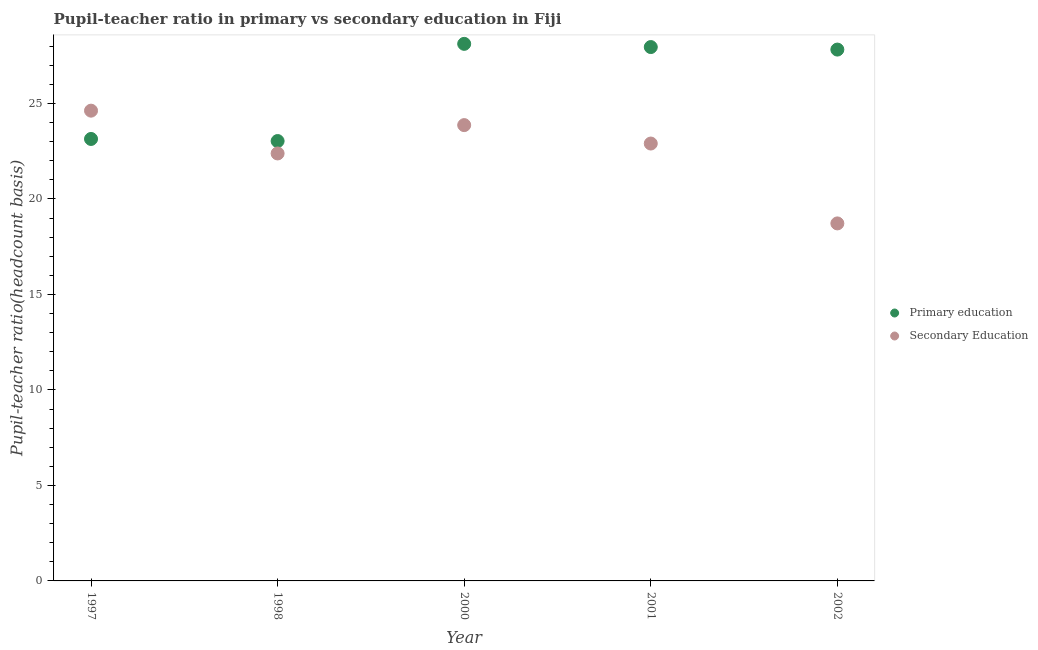How many different coloured dotlines are there?
Give a very brief answer. 2. Is the number of dotlines equal to the number of legend labels?
Your response must be concise. Yes. What is the pupil-teacher ratio in primary education in 2002?
Give a very brief answer. 27.82. Across all years, what is the maximum pupil teacher ratio on secondary education?
Your answer should be very brief. 24.62. Across all years, what is the minimum pupil teacher ratio on secondary education?
Provide a succinct answer. 18.72. In which year was the pupil-teacher ratio in primary education minimum?
Ensure brevity in your answer.  1998. What is the total pupil teacher ratio on secondary education in the graph?
Make the answer very short. 112.5. What is the difference between the pupil teacher ratio on secondary education in 2000 and that in 2001?
Your answer should be very brief. 0.97. What is the difference between the pupil teacher ratio on secondary education in 2001 and the pupil-teacher ratio in primary education in 2002?
Provide a succinct answer. -4.92. What is the average pupil teacher ratio on secondary education per year?
Provide a succinct answer. 22.5. In the year 1997, what is the difference between the pupil teacher ratio on secondary education and pupil-teacher ratio in primary education?
Make the answer very short. 1.48. In how many years, is the pupil-teacher ratio in primary education greater than 11?
Offer a very short reply. 5. What is the ratio of the pupil-teacher ratio in primary education in 2000 to that in 2001?
Keep it short and to the point. 1.01. Is the pupil teacher ratio on secondary education in 1998 less than that in 2000?
Keep it short and to the point. Yes. What is the difference between the highest and the second highest pupil teacher ratio on secondary education?
Your response must be concise. 0.76. What is the difference between the highest and the lowest pupil teacher ratio on secondary education?
Your answer should be compact. 5.9. In how many years, is the pupil-teacher ratio in primary education greater than the average pupil-teacher ratio in primary education taken over all years?
Provide a short and direct response. 3. Is the sum of the pupil teacher ratio on secondary education in 2001 and 2002 greater than the maximum pupil-teacher ratio in primary education across all years?
Your answer should be very brief. Yes. Does the pupil teacher ratio on secondary education monotonically increase over the years?
Ensure brevity in your answer.  No. How are the legend labels stacked?
Make the answer very short. Vertical. What is the title of the graph?
Offer a terse response. Pupil-teacher ratio in primary vs secondary education in Fiji. What is the label or title of the Y-axis?
Provide a short and direct response. Pupil-teacher ratio(headcount basis). What is the Pupil-teacher ratio(headcount basis) in Primary education in 1997?
Ensure brevity in your answer.  23.14. What is the Pupil-teacher ratio(headcount basis) of Secondary Education in 1997?
Ensure brevity in your answer.  24.62. What is the Pupil-teacher ratio(headcount basis) in Primary education in 1998?
Ensure brevity in your answer.  23.03. What is the Pupil-teacher ratio(headcount basis) of Secondary Education in 1998?
Your answer should be compact. 22.38. What is the Pupil-teacher ratio(headcount basis) of Primary education in 2000?
Your response must be concise. 28.12. What is the Pupil-teacher ratio(headcount basis) in Secondary Education in 2000?
Provide a short and direct response. 23.87. What is the Pupil-teacher ratio(headcount basis) in Primary education in 2001?
Your answer should be compact. 27.95. What is the Pupil-teacher ratio(headcount basis) of Secondary Education in 2001?
Ensure brevity in your answer.  22.9. What is the Pupil-teacher ratio(headcount basis) of Primary education in 2002?
Your response must be concise. 27.82. What is the Pupil-teacher ratio(headcount basis) of Secondary Education in 2002?
Your answer should be very brief. 18.72. Across all years, what is the maximum Pupil-teacher ratio(headcount basis) of Primary education?
Make the answer very short. 28.12. Across all years, what is the maximum Pupil-teacher ratio(headcount basis) of Secondary Education?
Offer a very short reply. 24.62. Across all years, what is the minimum Pupil-teacher ratio(headcount basis) of Primary education?
Your answer should be very brief. 23.03. Across all years, what is the minimum Pupil-teacher ratio(headcount basis) of Secondary Education?
Provide a succinct answer. 18.72. What is the total Pupil-teacher ratio(headcount basis) of Primary education in the graph?
Ensure brevity in your answer.  130.07. What is the total Pupil-teacher ratio(headcount basis) in Secondary Education in the graph?
Give a very brief answer. 112.5. What is the difference between the Pupil-teacher ratio(headcount basis) of Primary education in 1997 and that in 1998?
Give a very brief answer. 0.11. What is the difference between the Pupil-teacher ratio(headcount basis) of Secondary Education in 1997 and that in 1998?
Provide a succinct answer. 2.24. What is the difference between the Pupil-teacher ratio(headcount basis) in Primary education in 1997 and that in 2000?
Keep it short and to the point. -4.98. What is the difference between the Pupil-teacher ratio(headcount basis) in Secondary Education in 1997 and that in 2000?
Your answer should be very brief. 0.76. What is the difference between the Pupil-teacher ratio(headcount basis) in Primary education in 1997 and that in 2001?
Your response must be concise. -4.81. What is the difference between the Pupil-teacher ratio(headcount basis) of Secondary Education in 1997 and that in 2001?
Make the answer very short. 1.72. What is the difference between the Pupil-teacher ratio(headcount basis) in Primary education in 1997 and that in 2002?
Provide a succinct answer. -4.68. What is the difference between the Pupil-teacher ratio(headcount basis) in Secondary Education in 1997 and that in 2002?
Offer a terse response. 5.9. What is the difference between the Pupil-teacher ratio(headcount basis) in Primary education in 1998 and that in 2000?
Provide a short and direct response. -5.09. What is the difference between the Pupil-teacher ratio(headcount basis) of Secondary Education in 1998 and that in 2000?
Offer a very short reply. -1.48. What is the difference between the Pupil-teacher ratio(headcount basis) in Primary education in 1998 and that in 2001?
Give a very brief answer. -4.92. What is the difference between the Pupil-teacher ratio(headcount basis) of Secondary Education in 1998 and that in 2001?
Provide a short and direct response. -0.52. What is the difference between the Pupil-teacher ratio(headcount basis) in Primary education in 1998 and that in 2002?
Your response must be concise. -4.79. What is the difference between the Pupil-teacher ratio(headcount basis) of Secondary Education in 1998 and that in 2002?
Keep it short and to the point. 3.66. What is the difference between the Pupil-teacher ratio(headcount basis) of Primary education in 2000 and that in 2001?
Provide a succinct answer. 0.17. What is the difference between the Pupil-teacher ratio(headcount basis) in Secondary Education in 2000 and that in 2001?
Your answer should be very brief. 0.97. What is the difference between the Pupil-teacher ratio(headcount basis) in Primary education in 2000 and that in 2002?
Provide a succinct answer. 0.3. What is the difference between the Pupil-teacher ratio(headcount basis) of Secondary Education in 2000 and that in 2002?
Offer a very short reply. 5.15. What is the difference between the Pupil-teacher ratio(headcount basis) of Primary education in 2001 and that in 2002?
Offer a terse response. 0.13. What is the difference between the Pupil-teacher ratio(headcount basis) in Secondary Education in 2001 and that in 2002?
Keep it short and to the point. 4.18. What is the difference between the Pupil-teacher ratio(headcount basis) of Primary education in 1997 and the Pupil-teacher ratio(headcount basis) of Secondary Education in 1998?
Keep it short and to the point. 0.76. What is the difference between the Pupil-teacher ratio(headcount basis) of Primary education in 1997 and the Pupil-teacher ratio(headcount basis) of Secondary Education in 2000?
Make the answer very short. -0.73. What is the difference between the Pupil-teacher ratio(headcount basis) of Primary education in 1997 and the Pupil-teacher ratio(headcount basis) of Secondary Education in 2001?
Keep it short and to the point. 0.24. What is the difference between the Pupil-teacher ratio(headcount basis) of Primary education in 1997 and the Pupil-teacher ratio(headcount basis) of Secondary Education in 2002?
Make the answer very short. 4.42. What is the difference between the Pupil-teacher ratio(headcount basis) in Primary education in 1998 and the Pupil-teacher ratio(headcount basis) in Secondary Education in 2000?
Offer a very short reply. -0.83. What is the difference between the Pupil-teacher ratio(headcount basis) in Primary education in 1998 and the Pupil-teacher ratio(headcount basis) in Secondary Education in 2001?
Keep it short and to the point. 0.13. What is the difference between the Pupil-teacher ratio(headcount basis) in Primary education in 1998 and the Pupil-teacher ratio(headcount basis) in Secondary Education in 2002?
Your response must be concise. 4.31. What is the difference between the Pupil-teacher ratio(headcount basis) in Primary education in 2000 and the Pupil-teacher ratio(headcount basis) in Secondary Education in 2001?
Make the answer very short. 5.22. What is the difference between the Pupil-teacher ratio(headcount basis) of Primary education in 2000 and the Pupil-teacher ratio(headcount basis) of Secondary Education in 2002?
Your response must be concise. 9.4. What is the difference between the Pupil-teacher ratio(headcount basis) in Primary education in 2001 and the Pupil-teacher ratio(headcount basis) in Secondary Education in 2002?
Your answer should be compact. 9.23. What is the average Pupil-teacher ratio(headcount basis) in Primary education per year?
Offer a terse response. 26.01. What is the average Pupil-teacher ratio(headcount basis) in Secondary Education per year?
Provide a short and direct response. 22.5. In the year 1997, what is the difference between the Pupil-teacher ratio(headcount basis) in Primary education and Pupil-teacher ratio(headcount basis) in Secondary Education?
Give a very brief answer. -1.48. In the year 1998, what is the difference between the Pupil-teacher ratio(headcount basis) in Primary education and Pupil-teacher ratio(headcount basis) in Secondary Education?
Provide a succinct answer. 0.65. In the year 2000, what is the difference between the Pupil-teacher ratio(headcount basis) in Primary education and Pupil-teacher ratio(headcount basis) in Secondary Education?
Offer a terse response. 4.25. In the year 2001, what is the difference between the Pupil-teacher ratio(headcount basis) in Primary education and Pupil-teacher ratio(headcount basis) in Secondary Education?
Provide a succinct answer. 5.05. In the year 2002, what is the difference between the Pupil-teacher ratio(headcount basis) of Primary education and Pupil-teacher ratio(headcount basis) of Secondary Education?
Ensure brevity in your answer.  9.1. What is the ratio of the Pupil-teacher ratio(headcount basis) of Primary education in 1997 to that in 1998?
Give a very brief answer. 1. What is the ratio of the Pupil-teacher ratio(headcount basis) in Secondary Education in 1997 to that in 1998?
Your response must be concise. 1.1. What is the ratio of the Pupil-teacher ratio(headcount basis) in Primary education in 1997 to that in 2000?
Your answer should be very brief. 0.82. What is the ratio of the Pupil-teacher ratio(headcount basis) in Secondary Education in 1997 to that in 2000?
Provide a short and direct response. 1.03. What is the ratio of the Pupil-teacher ratio(headcount basis) in Primary education in 1997 to that in 2001?
Your response must be concise. 0.83. What is the ratio of the Pupil-teacher ratio(headcount basis) of Secondary Education in 1997 to that in 2001?
Provide a short and direct response. 1.08. What is the ratio of the Pupil-teacher ratio(headcount basis) of Primary education in 1997 to that in 2002?
Give a very brief answer. 0.83. What is the ratio of the Pupil-teacher ratio(headcount basis) of Secondary Education in 1997 to that in 2002?
Offer a very short reply. 1.32. What is the ratio of the Pupil-teacher ratio(headcount basis) in Primary education in 1998 to that in 2000?
Offer a very short reply. 0.82. What is the ratio of the Pupil-teacher ratio(headcount basis) of Secondary Education in 1998 to that in 2000?
Ensure brevity in your answer.  0.94. What is the ratio of the Pupil-teacher ratio(headcount basis) in Primary education in 1998 to that in 2001?
Your answer should be compact. 0.82. What is the ratio of the Pupil-teacher ratio(headcount basis) in Secondary Education in 1998 to that in 2001?
Your response must be concise. 0.98. What is the ratio of the Pupil-teacher ratio(headcount basis) in Primary education in 1998 to that in 2002?
Provide a succinct answer. 0.83. What is the ratio of the Pupil-teacher ratio(headcount basis) in Secondary Education in 1998 to that in 2002?
Ensure brevity in your answer.  1.2. What is the ratio of the Pupil-teacher ratio(headcount basis) of Secondary Education in 2000 to that in 2001?
Provide a short and direct response. 1.04. What is the ratio of the Pupil-teacher ratio(headcount basis) in Primary education in 2000 to that in 2002?
Your answer should be very brief. 1.01. What is the ratio of the Pupil-teacher ratio(headcount basis) of Secondary Education in 2000 to that in 2002?
Offer a terse response. 1.27. What is the ratio of the Pupil-teacher ratio(headcount basis) in Primary education in 2001 to that in 2002?
Keep it short and to the point. 1. What is the ratio of the Pupil-teacher ratio(headcount basis) in Secondary Education in 2001 to that in 2002?
Give a very brief answer. 1.22. What is the difference between the highest and the second highest Pupil-teacher ratio(headcount basis) of Primary education?
Your answer should be compact. 0.17. What is the difference between the highest and the second highest Pupil-teacher ratio(headcount basis) of Secondary Education?
Provide a short and direct response. 0.76. What is the difference between the highest and the lowest Pupil-teacher ratio(headcount basis) of Primary education?
Your answer should be compact. 5.09. What is the difference between the highest and the lowest Pupil-teacher ratio(headcount basis) in Secondary Education?
Your answer should be compact. 5.9. 